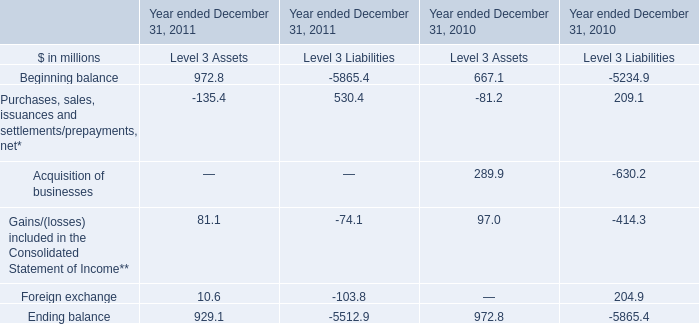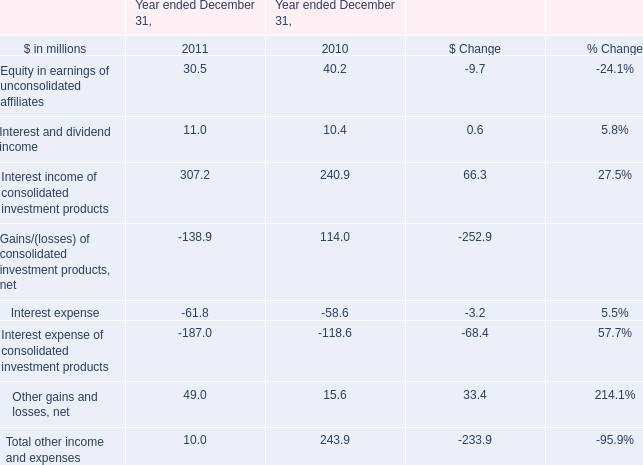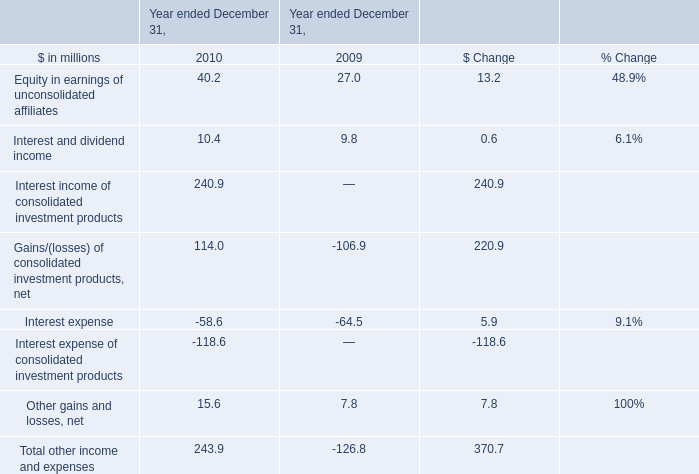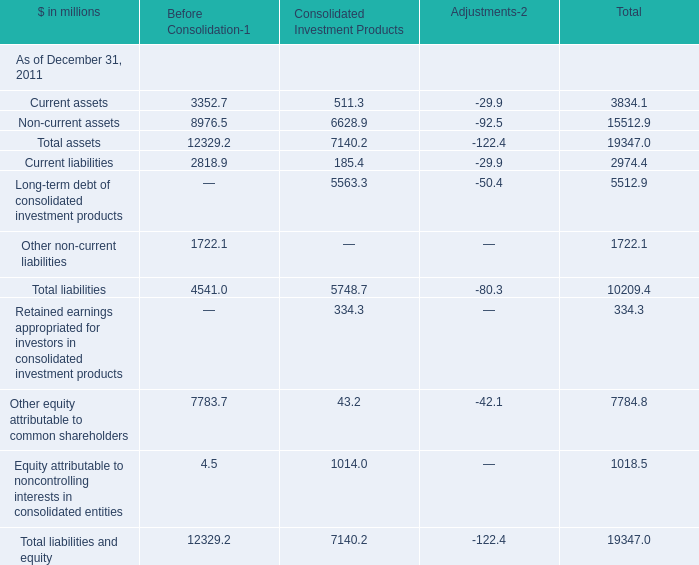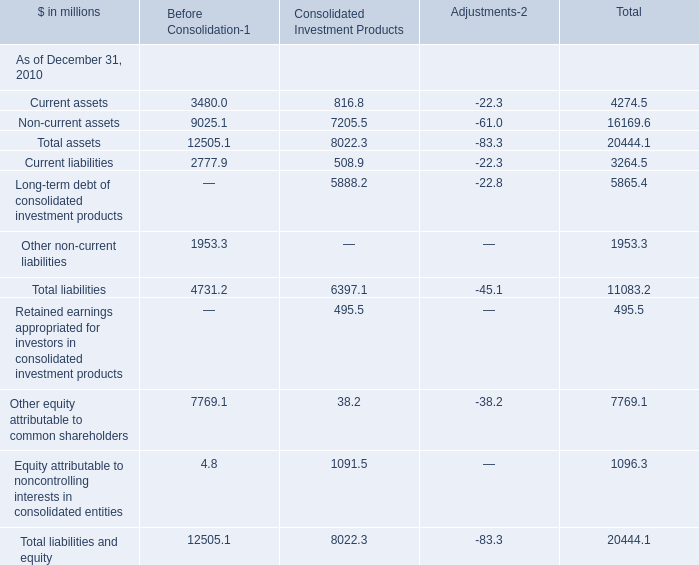How many elements show negative value in 2010 for Before Consolidation-1? 
Answer: 0. 